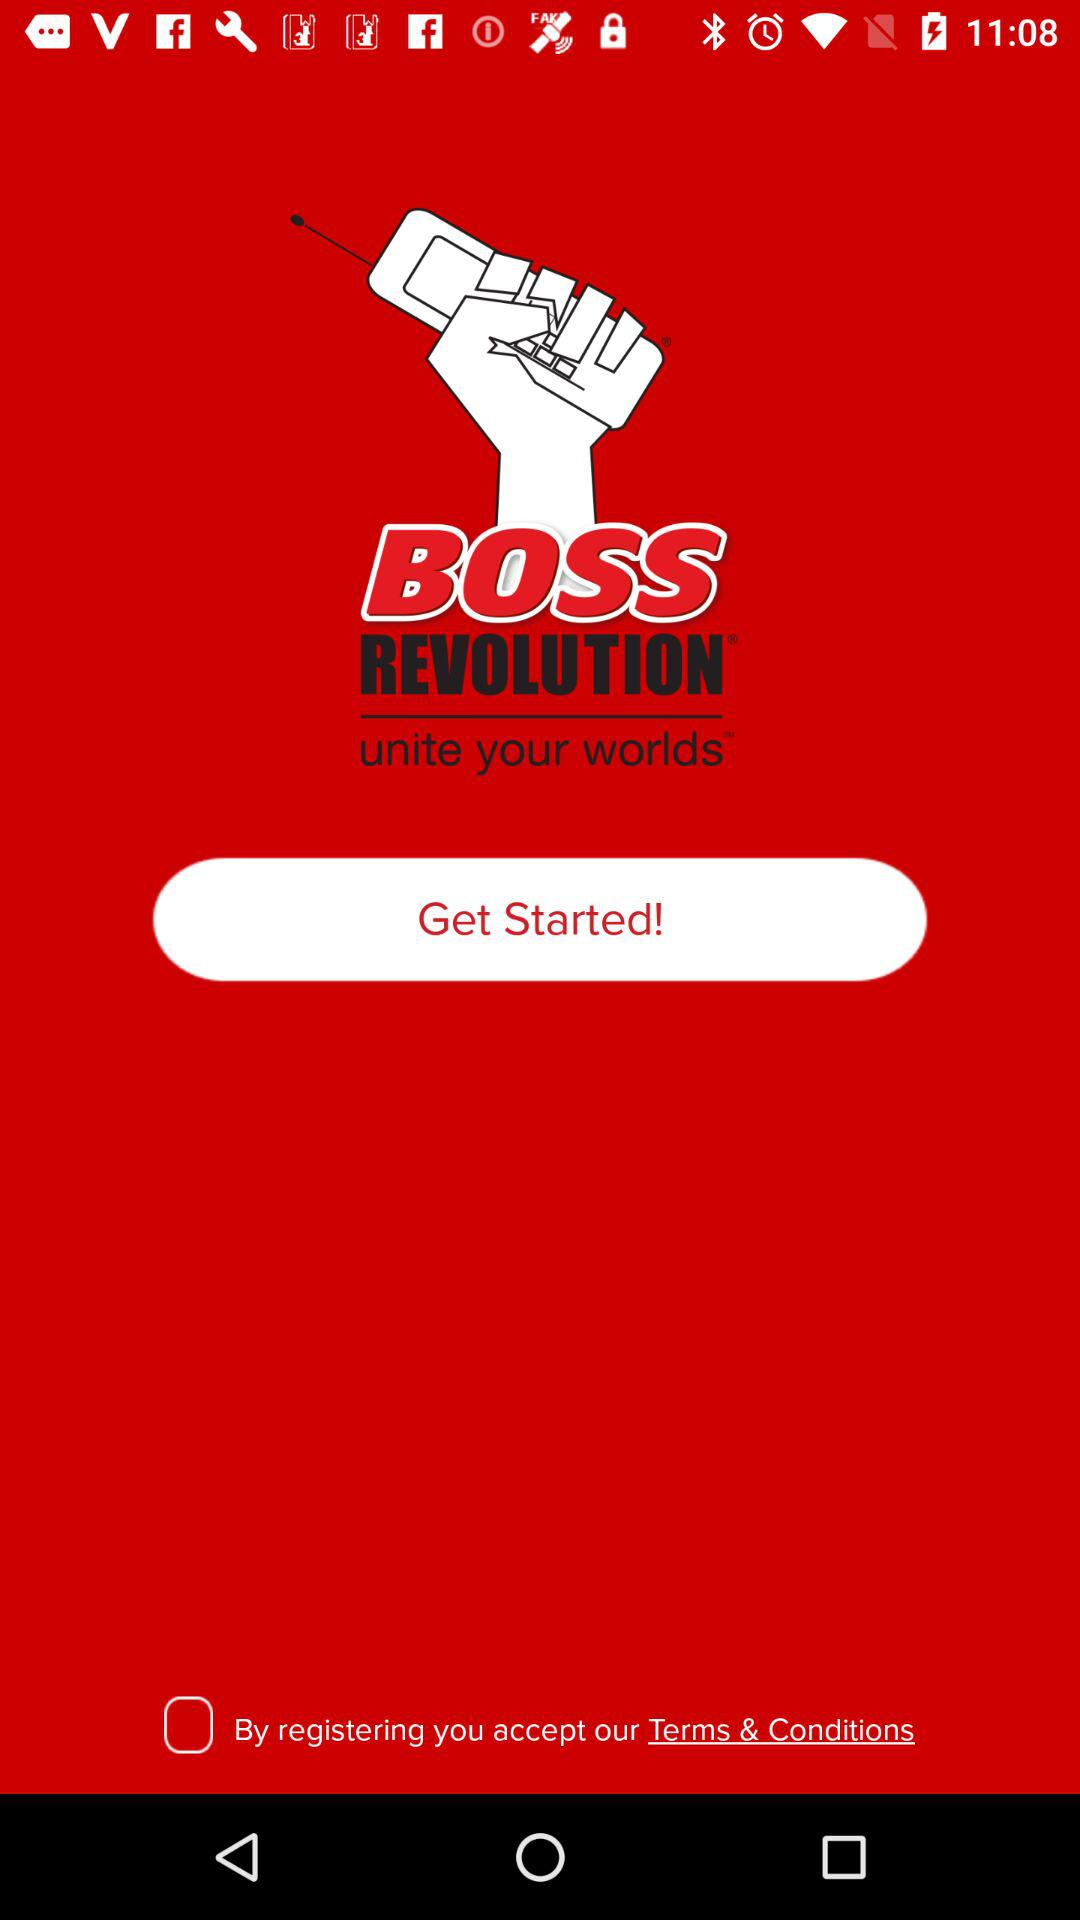What is the app name? The app name is "BOSS REVOLUTION". 